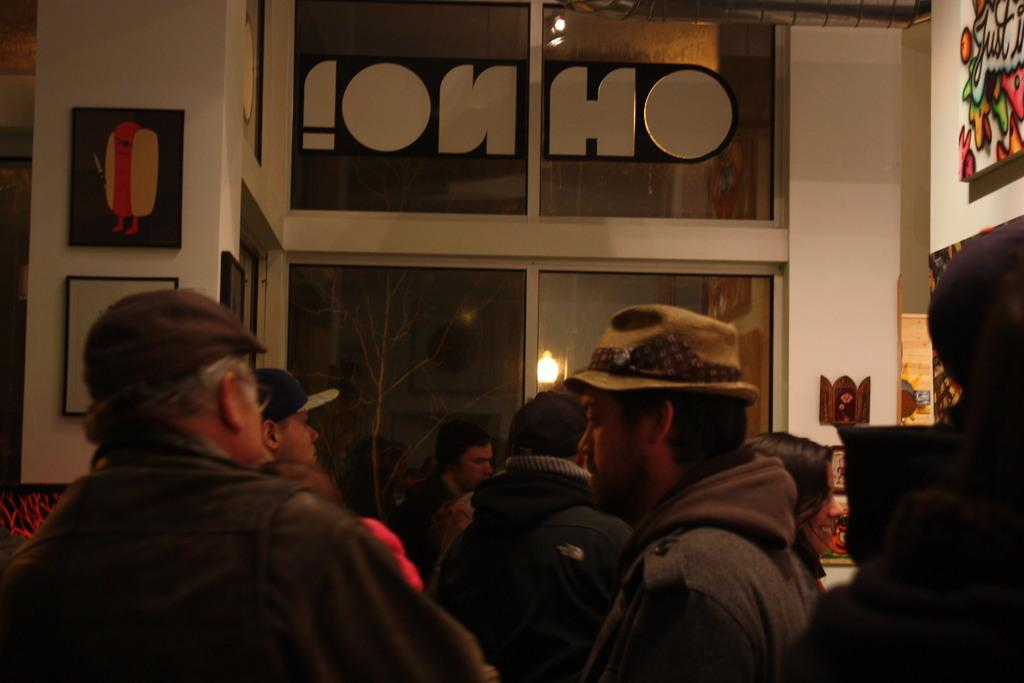How many people are in the group that is visible in the image? There is a group of people in the image, but the exact number is not specified. What type of headwear can be seen on some of the people in the group? Some people in the group are wearing caps. What can be seen in the background of the image? There are lights and paintings on the wall visible in the background of the image. What type of basket is being used by the judge in the image? There is no judge or basket present in the image. How does the breath of the people in the group affect the image? The breath of the people in the group does not affect the image, as it is a still photograph. 